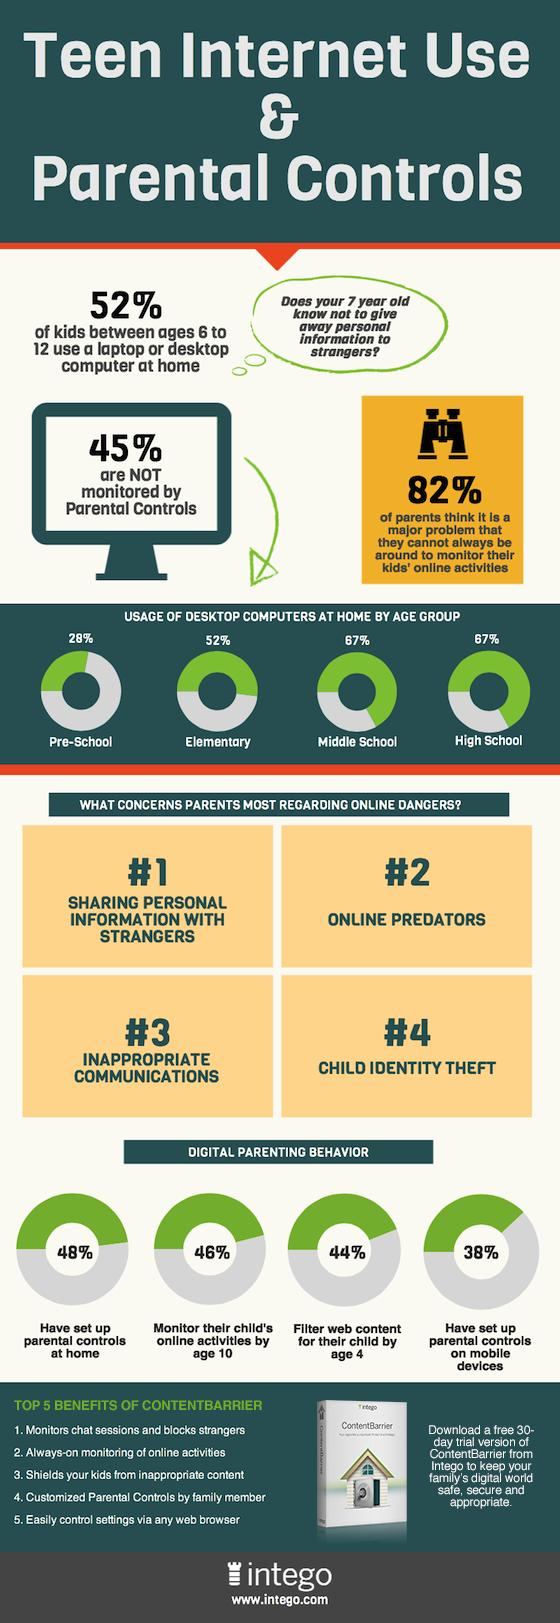Indicate a few pertinent items in this graphic. According to a recent survey, 67% of high school students use desktop computers at home. According to a recent survey, 52% of children who use computers at home are of elementary school age. A majority of parents, or 38%, have implemented parental controls on their mobile devices. The matter of greatest concern for parents regarding their children's online safety is the presence of online predators. A significant percentage of children who use computers at home are not being adequately supervised by parental controls, with 45% falling into this category. 